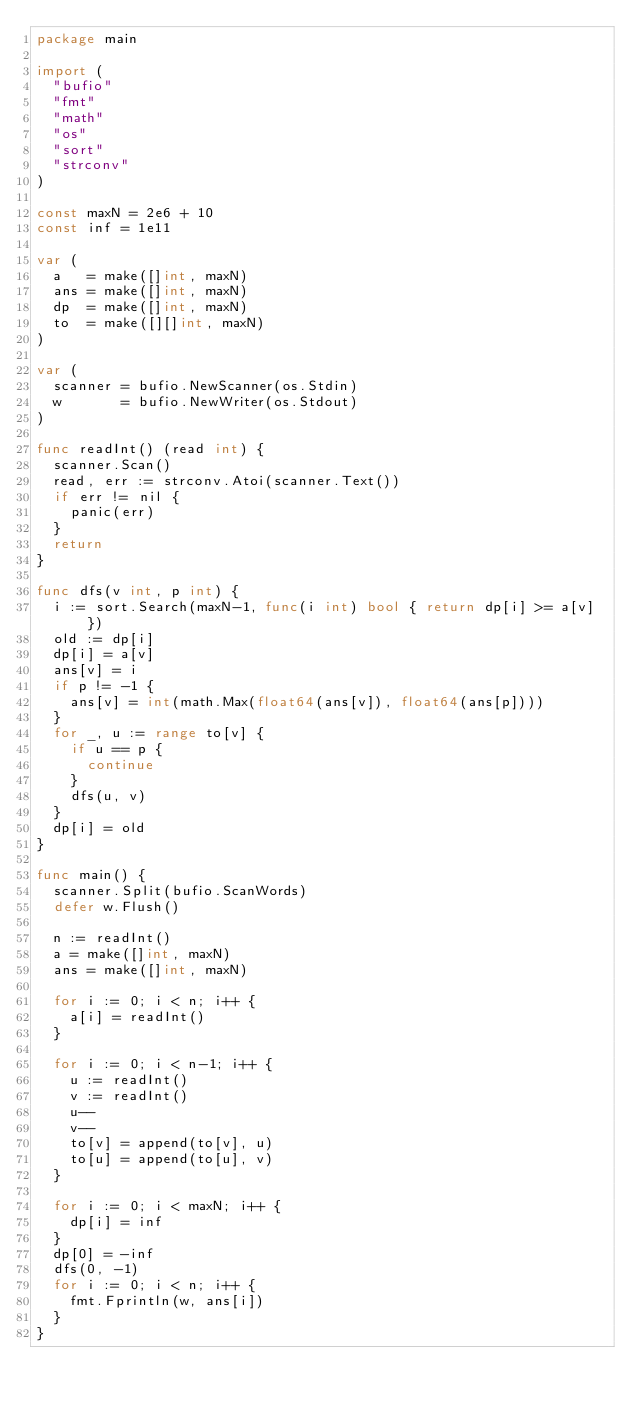Convert code to text. <code><loc_0><loc_0><loc_500><loc_500><_Go_>package main

import (
	"bufio"
	"fmt"
	"math"
	"os"
	"sort"
	"strconv"
)

const maxN = 2e6 + 10
const inf = 1e11

var (
	a   = make([]int, maxN)
	ans = make([]int, maxN)
	dp  = make([]int, maxN)
	to  = make([][]int, maxN)
)

var (
	scanner = bufio.NewScanner(os.Stdin)
	w       = bufio.NewWriter(os.Stdout)
)

func readInt() (read int) {
	scanner.Scan()
	read, err := strconv.Atoi(scanner.Text())
	if err != nil {
		panic(err)
	}
	return
}

func dfs(v int, p int) {
	i := sort.Search(maxN-1, func(i int) bool { return dp[i] >= a[v] })
	old := dp[i]
	dp[i] = a[v]
	ans[v] = i
	if p != -1 {
		ans[v] = int(math.Max(float64(ans[v]), float64(ans[p])))
	}
	for _, u := range to[v] {
		if u == p {
			continue
		}
		dfs(u, v)
	}
	dp[i] = old
}

func main() {
	scanner.Split(bufio.ScanWords)
	defer w.Flush()

	n := readInt()
	a = make([]int, maxN)
	ans = make([]int, maxN)

	for i := 0; i < n; i++ {
		a[i] = readInt()
	}

	for i := 0; i < n-1; i++ {
		u := readInt()
		v := readInt()
		u--
		v--
		to[v] = append(to[v], u)
		to[u] = append(to[u], v)
	}

	for i := 0; i < maxN; i++ {
		dp[i] = inf
	}
	dp[0] = -inf
	dfs(0, -1)
	for i := 0; i < n; i++ {
		fmt.Fprintln(w, ans[i])
	}
}
</code> 